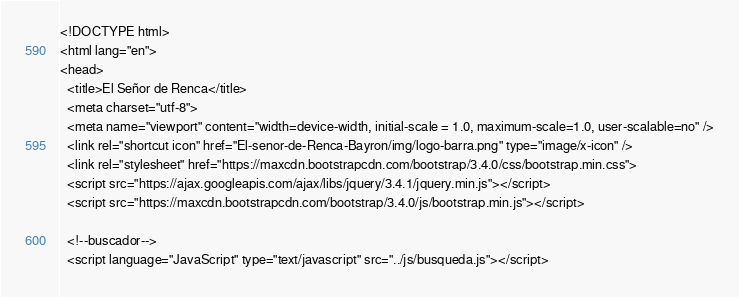Convert code to text. <code><loc_0><loc_0><loc_500><loc_500><_PHP_><!DOCTYPE html>
<html lang="en">
<head>
  <title>El Señor de Renca</title>
  <meta charset="utf-8">
  <meta name="viewport" content="width=device-width, initial-scale = 1.0, maximum-scale=1.0, user-scalable=no" />
  <link rel="shortcut icon" href="El-senor-de-Renca-Bayron/img/logo-barra.png" type="image/x-icon" />
  <link rel="stylesheet" href="https://maxcdn.bootstrapcdn.com/bootstrap/3.4.0/css/bootstrap.min.css">
  <script src="https://ajax.googleapis.com/ajax/libs/jquery/3.4.1/jquery.min.js"></script>
  <script src="https://maxcdn.bootstrapcdn.com/bootstrap/3.4.0/js/bootstrap.min.js"></script>

  <!--buscador-->
  <script language="JavaScript" type="text/javascript" src="../js/busqueda.js"></script></code> 